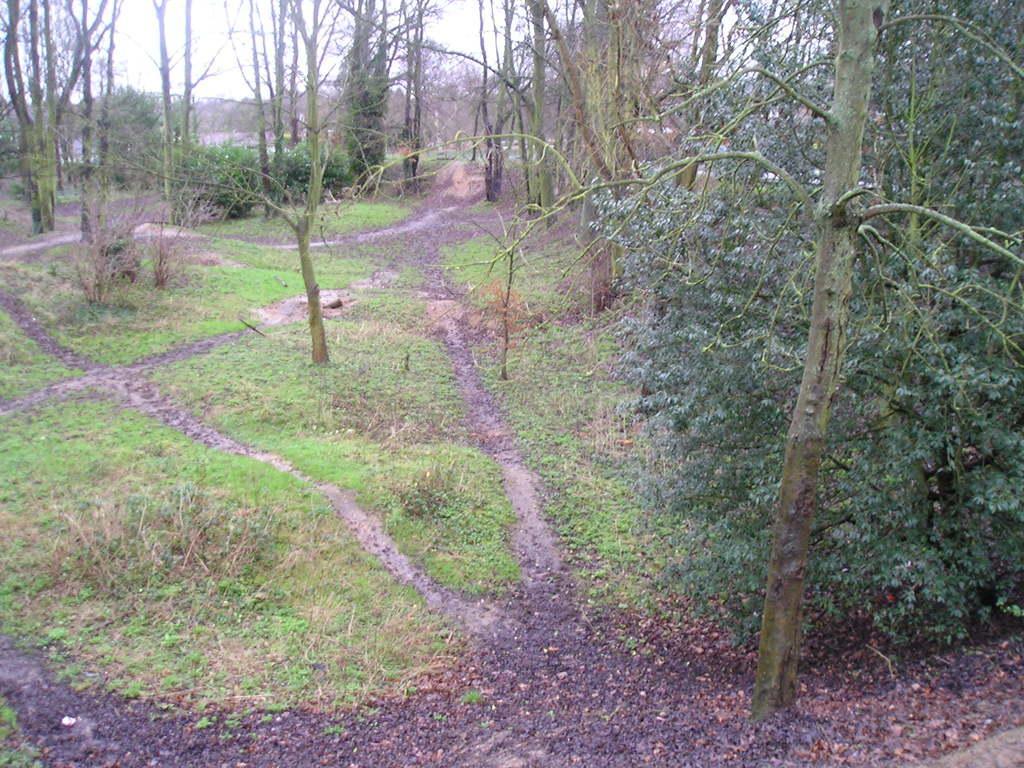How would you summarize this image in a sentence or two? In this image, we can see so many trees, plants and grass. Background there is a sky. 